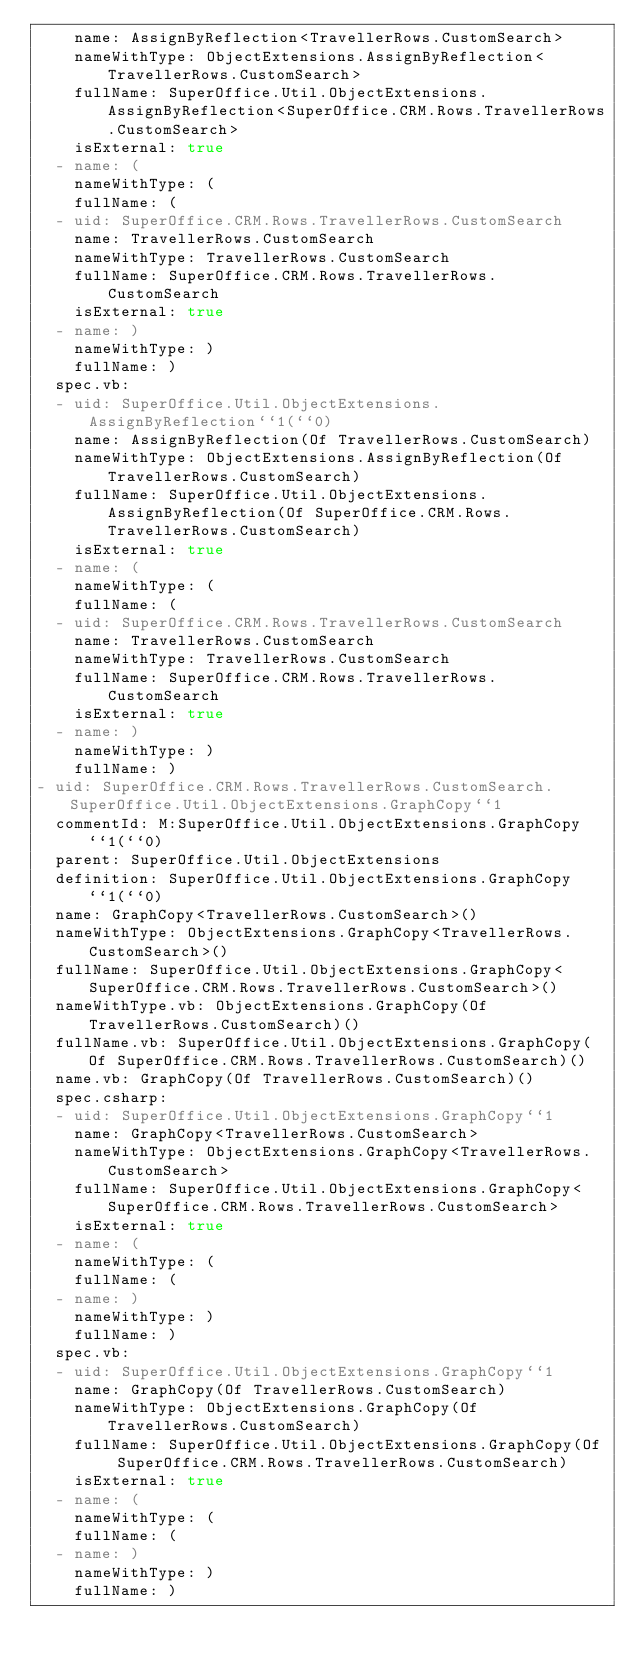Convert code to text. <code><loc_0><loc_0><loc_500><loc_500><_YAML_>    name: AssignByReflection<TravellerRows.CustomSearch>
    nameWithType: ObjectExtensions.AssignByReflection<TravellerRows.CustomSearch>
    fullName: SuperOffice.Util.ObjectExtensions.AssignByReflection<SuperOffice.CRM.Rows.TravellerRows.CustomSearch>
    isExternal: true
  - name: (
    nameWithType: (
    fullName: (
  - uid: SuperOffice.CRM.Rows.TravellerRows.CustomSearch
    name: TravellerRows.CustomSearch
    nameWithType: TravellerRows.CustomSearch
    fullName: SuperOffice.CRM.Rows.TravellerRows.CustomSearch
    isExternal: true
  - name: )
    nameWithType: )
    fullName: )
  spec.vb:
  - uid: SuperOffice.Util.ObjectExtensions.AssignByReflection``1(``0)
    name: AssignByReflection(Of TravellerRows.CustomSearch)
    nameWithType: ObjectExtensions.AssignByReflection(Of TravellerRows.CustomSearch)
    fullName: SuperOffice.Util.ObjectExtensions.AssignByReflection(Of SuperOffice.CRM.Rows.TravellerRows.CustomSearch)
    isExternal: true
  - name: (
    nameWithType: (
    fullName: (
  - uid: SuperOffice.CRM.Rows.TravellerRows.CustomSearch
    name: TravellerRows.CustomSearch
    nameWithType: TravellerRows.CustomSearch
    fullName: SuperOffice.CRM.Rows.TravellerRows.CustomSearch
    isExternal: true
  - name: )
    nameWithType: )
    fullName: )
- uid: SuperOffice.CRM.Rows.TravellerRows.CustomSearch.SuperOffice.Util.ObjectExtensions.GraphCopy``1
  commentId: M:SuperOffice.Util.ObjectExtensions.GraphCopy``1(``0)
  parent: SuperOffice.Util.ObjectExtensions
  definition: SuperOffice.Util.ObjectExtensions.GraphCopy``1(``0)
  name: GraphCopy<TravellerRows.CustomSearch>()
  nameWithType: ObjectExtensions.GraphCopy<TravellerRows.CustomSearch>()
  fullName: SuperOffice.Util.ObjectExtensions.GraphCopy<SuperOffice.CRM.Rows.TravellerRows.CustomSearch>()
  nameWithType.vb: ObjectExtensions.GraphCopy(Of TravellerRows.CustomSearch)()
  fullName.vb: SuperOffice.Util.ObjectExtensions.GraphCopy(Of SuperOffice.CRM.Rows.TravellerRows.CustomSearch)()
  name.vb: GraphCopy(Of TravellerRows.CustomSearch)()
  spec.csharp:
  - uid: SuperOffice.Util.ObjectExtensions.GraphCopy``1
    name: GraphCopy<TravellerRows.CustomSearch>
    nameWithType: ObjectExtensions.GraphCopy<TravellerRows.CustomSearch>
    fullName: SuperOffice.Util.ObjectExtensions.GraphCopy<SuperOffice.CRM.Rows.TravellerRows.CustomSearch>
    isExternal: true
  - name: (
    nameWithType: (
    fullName: (
  - name: )
    nameWithType: )
    fullName: )
  spec.vb:
  - uid: SuperOffice.Util.ObjectExtensions.GraphCopy``1
    name: GraphCopy(Of TravellerRows.CustomSearch)
    nameWithType: ObjectExtensions.GraphCopy(Of TravellerRows.CustomSearch)
    fullName: SuperOffice.Util.ObjectExtensions.GraphCopy(Of SuperOffice.CRM.Rows.TravellerRows.CustomSearch)
    isExternal: true
  - name: (
    nameWithType: (
    fullName: (
  - name: )
    nameWithType: )
    fullName: )</code> 